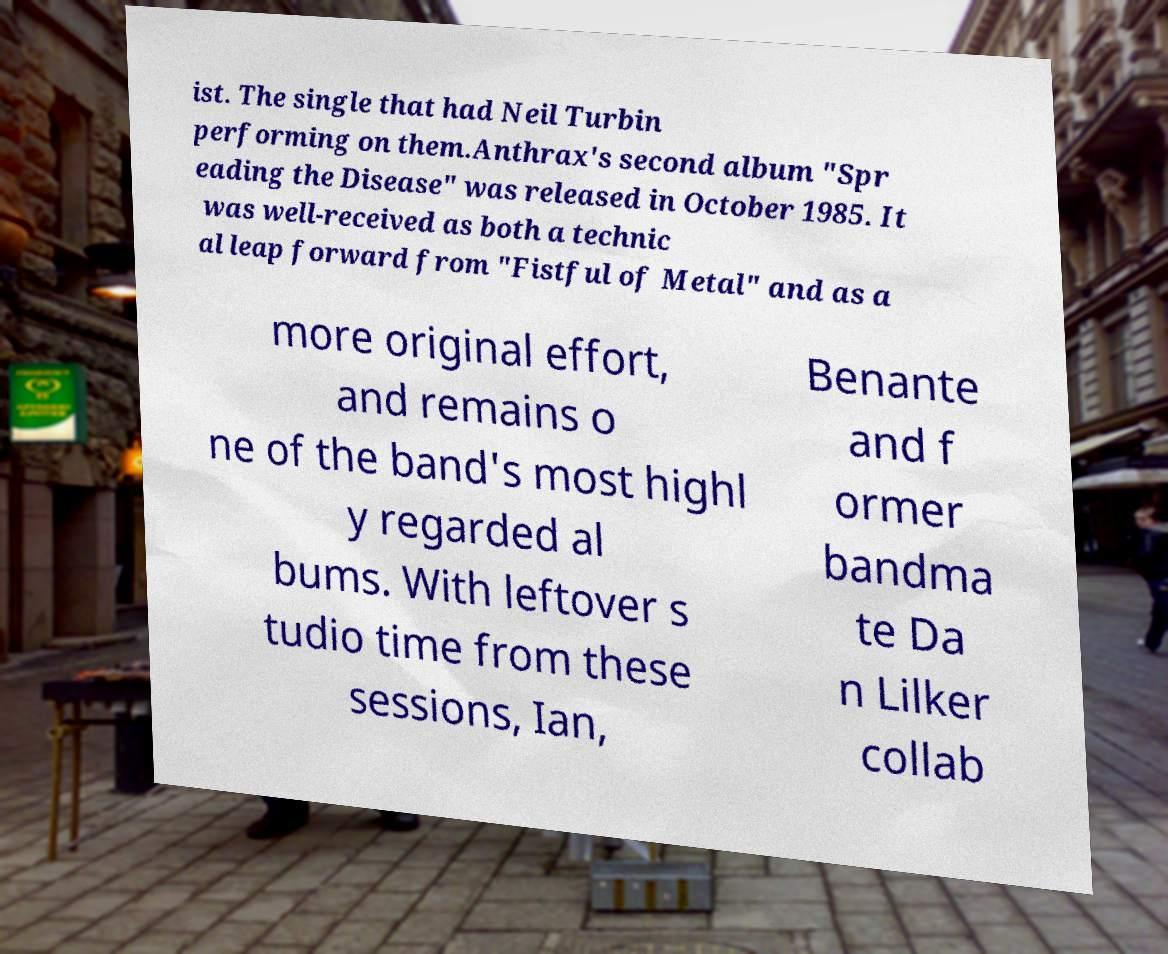Please read and relay the text visible in this image. What does it say? ist. The single that had Neil Turbin performing on them.Anthrax's second album "Spr eading the Disease" was released in October 1985. It was well-received as both a technic al leap forward from "Fistful of Metal" and as a more original effort, and remains o ne of the band's most highl y regarded al bums. With leftover s tudio time from these sessions, Ian, Benante and f ormer bandma te Da n Lilker collab 